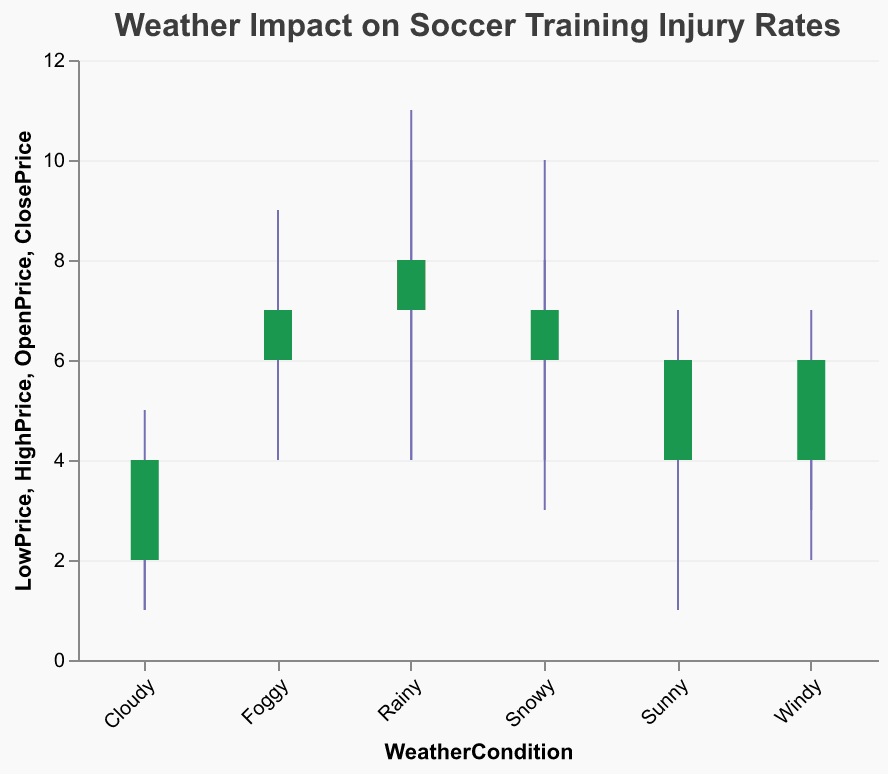What is the title of the figure? The title of the figure is centered at the top and reads: "Weather Impact on Soccer Training Injury Rates."
Answer: Weather Impact on Soccer Training Injury Rates What are the possible weather conditions shown in the figure? The x-axis labels represent various weather conditions observed during soccer training. They are: Sunny, Rainy, Cloudy, Windy, Snowy, and Foggy.
Answer: Sunny, Rainy, Cloudy, Windy, Snowy, Foggy Which weather condition has the lowest "LowPrice" value? By examining the bottom of each candlestick, we see that the weather condition with the lowest "LowPrice" is Cloudy, with a value of 1.
Answer: Cloudy In which weather condition is the "OpenPrice" lower than the "ClosePrice"? In the plot, the colors of the candlesticks indicate the relation between "OpenPrice" and "ClosePrice". Green bars show where the "OpenPrice" is lower than the "ClosePrice". The conditions are: Sunny, Snowy, Rainy (second occurrence), Windy (second occurrence), Foggy.
Answer: Sunny, Snowy, Rainy (second occurrence), Windy (second occurrence), Foggy Which weather condition has the highest "HighPrice" value, and what is that value? By inspecting the top of each candlestick, the tallest one indicates the condition with the highest "HighPrice". For Rainy (second occurrence), the "HighPrice" is 11.
Answer: Rainy (second occurrence), 11 What is the range of the injury rates under "Foggy" conditions in the second occurrence? The range is determined by the difference between "HighPrice" and "LowPrice". For the second occurrence of Foggy, "HighPrice" is 8 and "LowPrice" is 4, so the range is 8 - 4 = 4.
Answer: 4 How many weather conditions have a larger "ClosePrice" than the "OpenPrice"? By counting the green candlesticks (where "ClosePrice" is greater than "OpenPrice"), we find that there are five such conditions: Sunny (first occurrence), Snowy, Rainy (second occurrence), Windy (second occurrence), and Foggy.
Answer: 5 During which weather condition is the difference between "HighPrice" and "LowPrice" the smallest? The difference between "HighPrice" and "LowPrice" for each weather condition is visible on the figure. The smallest difference, which is 3 - 1 = 2, is observed under Cloudy (second occurrence) conditions.
Answer: Cloudy (second occurrence) What's the average "OpenPrice" in all "Sunny" conditions? There are two "Sunny" conditions with "OpenPrice" values of 5 and 4. The sum is 5 + 4 = 9, and there are 2 occurrences, so the average is 9 / 2 = 4.5.
Answer: 4.5 Compare the "OpenPrice" values of "Sunny" and "Rainy" (first occurrence) conditions. Which one is higher? The "OpenPrice" for "Sunny" (first occurrence) is 5, and for "Rainy" (first occurrence) is 8. Hence, the "Rainy" condition has a higher "OpenPrice".
Answer: Rainy 